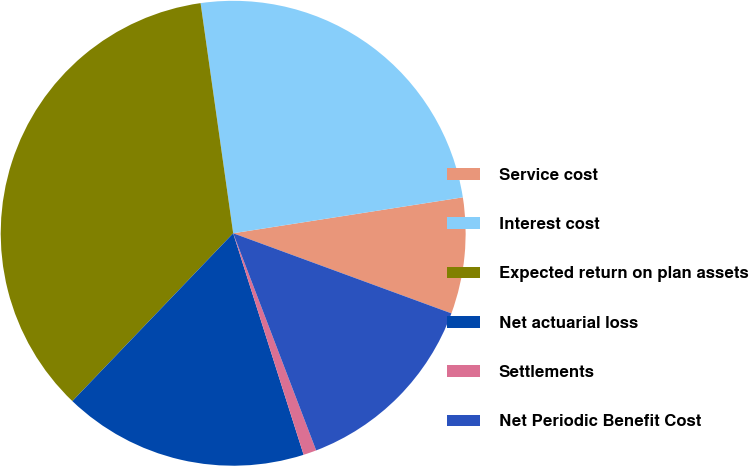Convert chart. <chart><loc_0><loc_0><loc_500><loc_500><pie_chart><fcel>Service cost<fcel>Interest cost<fcel>Expected return on plan assets<fcel>Net actuarial loss<fcel>Settlements<fcel>Net Periodic Benefit Cost<nl><fcel>8.07%<fcel>24.77%<fcel>35.6%<fcel>17.06%<fcel>0.91%<fcel>13.59%<nl></chart> 